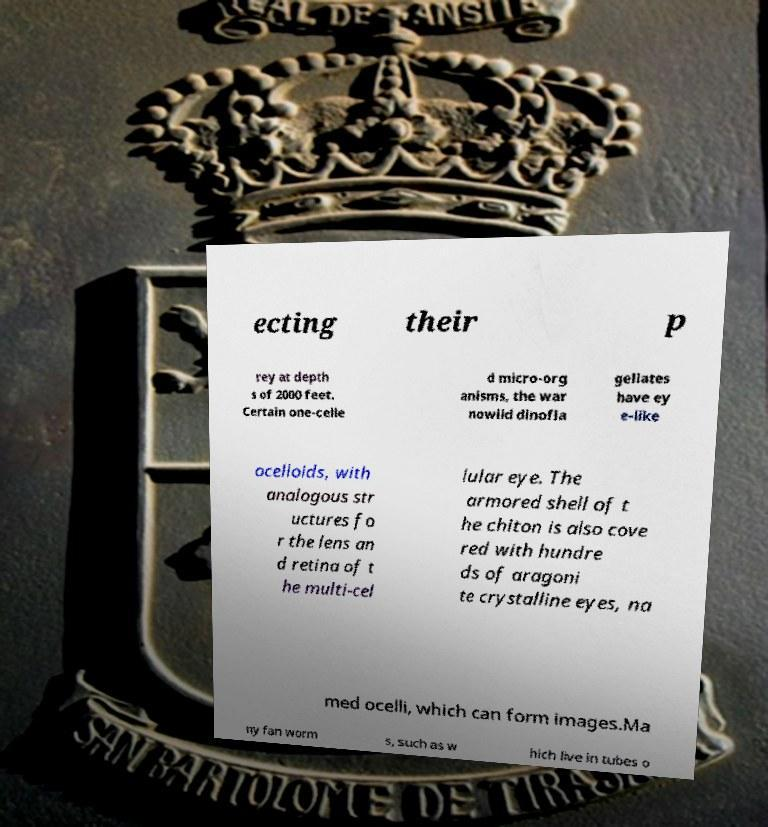Can you read and provide the text displayed in the image?This photo seems to have some interesting text. Can you extract and type it out for me? ecting their p rey at depth s of 2000 feet. Certain one-celle d micro-org anisms, the war nowiid dinofla gellates have ey e-like ocelloids, with analogous str uctures fo r the lens an d retina of t he multi-cel lular eye. The armored shell of t he chiton is also cove red with hundre ds of aragoni te crystalline eyes, na med ocelli, which can form images.Ma ny fan worm s, such as w hich live in tubes o 